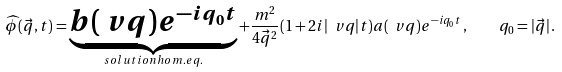<formula> <loc_0><loc_0><loc_500><loc_500>\widehat { \phi } ( \vec { q } , t ) = \underbrace { b ( \ v q ) e ^ { - i q _ { 0 } t } } _ { s o l u t i o n h o m . e q . } + \frac { m ^ { 2 } } { 4 \vec { q } ^ { 2 } } ( 1 + 2 i | \ v q | t ) a ( \ v q ) e ^ { - i q _ { 0 } t } \, , \quad q _ { 0 } = | \vec { q } | \, .</formula> 